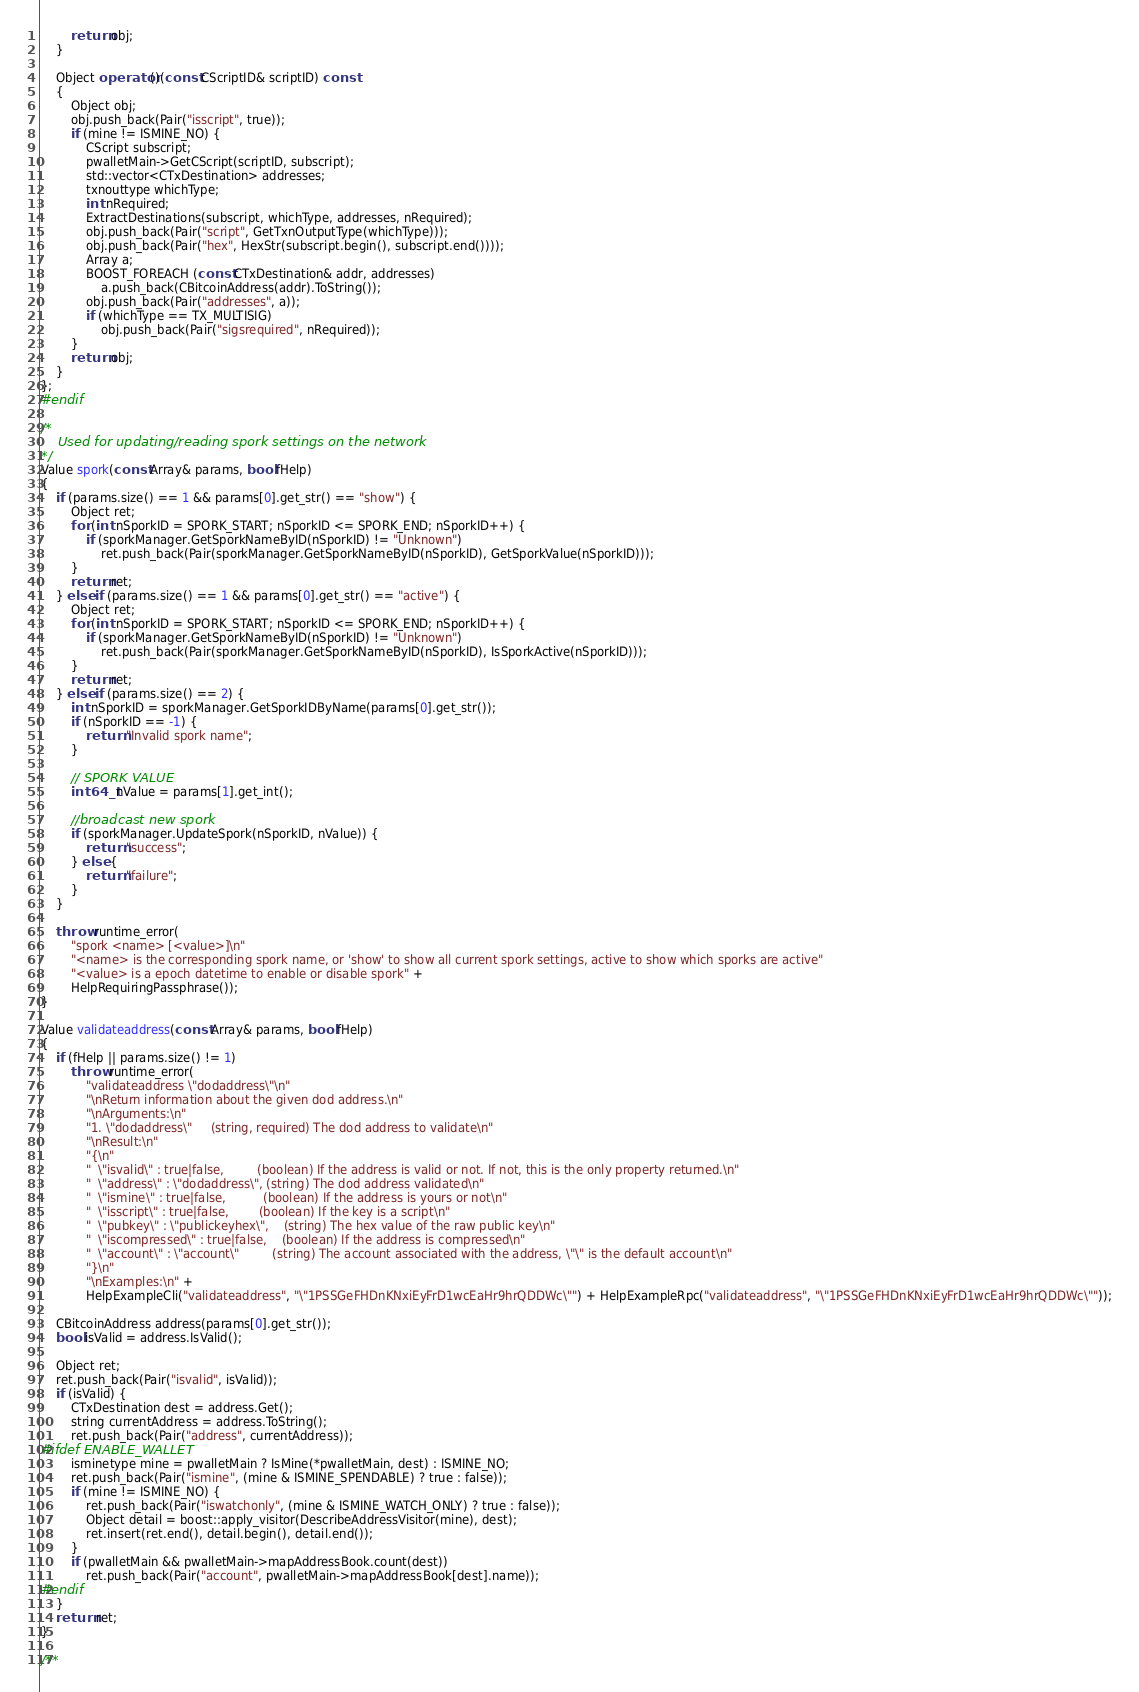<code> <loc_0><loc_0><loc_500><loc_500><_C++_>        return obj;
    }

    Object operator()(const CScriptID& scriptID) const
    {
        Object obj;
        obj.push_back(Pair("isscript", true));
        if (mine != ISMINE_NO) {
            CScript subscript;
            pwalletMain->GetCScript(scriptID, subscript);
            std::vector<CTxDestination> addresses;
            txnouttype whichType;
            int nRequired;
            ExtractDestinations(subscript, whichType, addresses, nRequired);
            obj.push_back(Pair("script", GetTxnOutputType(whichType)));
            obj.push_back(Pair("hex", HexStr(subscript.begin(), subscript.end())));
            Array a;
            BOOST_FOREACH (const CTxDestination& addr, addresses)
                a.push_back(CBitcoinAddress(addr).ToString());
            obj.push_back(Pair("addresses", a));
            if (whichType == TX_MULTISIG)
                obj.push_back(Pair("sigsrequired", nRequired));
        }
        return obj;
    }
};
#endif

/*
    Used for updating/reading spork settings on the network
*/
Value spork(const Array& params, bool fHelp)
{
    if (params.size() == 1 && params[0].get_str() == "show") {
        Object ret;
        for (int nSporkID = SPORK_START; nSporkID <= SPORK_END; nSporkID++) {
            if (sporkManager.GetSporkNameByID(nSporkID) != "Unknown")
                ret.push_back(Pair(sporkManager.GetSporkNameByID(nSporkID), GetSporkValue(nSporkID)));
        }
        return ret;
    } else if (params.size() == 1 && params[0].get_str() == "active") {
        Object ret;
        for (int nSporkID = SPORK_START; nSporkID <= SPORK_END; nSporkID++) {
            if (sporkManager.GetSporkNameByID(nSporkID) != "Unknown")
                ret.push_back(Pair(sporkManager.GetSporkNameByID(nSporkID), IsSporkActive(nSporkID)));
        }
        return ret;
    } else if (params.size() == 2) {
        int nSporkID = sporkManager.GetSporkIDByName(params[0].get_str());
        if (nSporkID == -1) {
            return "Invalid spork name";
        }

        // SPORK VALUE
        int64_t nValue = params[1].get_int();

        //broadcast new spork
        if (sporkManager.UpdateSpork(nSporkID, nValue)) {
            return "success";
        } else {
            return "failure";
        }
    }

    throw runtime_error(
        "spork <name> [<value>]\n"
        "<name> is the corresponding spork name, or 'show' to show all current spork settings, active to show which sporks are active"
        "<value> is a epoch datetime to enable or disable spork" +
        HelpRequiringPassphrase());
}

Value validateaddress(const Array& params, bool fHelp)
{
    if (fHelp || params.size() != 1)
        throw runtime_error(
            "validateaddress \"dodaddress\"\n"
            "\nReturn information about the given dod address.\n"
            "\nArguments:\n"
            "1. \"dodaddress\"     (string, required) The dod address to validate\n"
            "\nResult:\n"
            "{\n"
            "  \"isvalid\" : true|false,         (boolean) If the address is valid or not. If not, this is the only property returned.\n"
            "  \"address\" : \"dodaddress\", (string) The dod address validated\n"
            "  \"ismine\" : true|false,          (boolean) If the address is yours or not\n"
            "  \"isscript\" : true|false,        (boolean) If the key is a script\n"
            "  \"pubkey\" : \"publickeyhex\",    (string) The hex value of the raw public key\n"
            "  \"iscompressed\" : true|false,    (boolean) If the address is compressed\n"
            "  \"account\" : \"account\"         (string) The account associated with the address, \"\" is the default account\n"
            "}\n"
            "\nExamples:\n" +
            HelpExampleCli("validateaddress", "\"1PSSGeFHDnKNxiEyFrD1wcEaHr9hrQDDWc\"") + HelpExampleRpc("validateaddress", "\"1PSSGeFHDnKNxiEyFrD1wcEaHr9hrQDDWc\""));

    CBitcoinAddress address(params[0].get_str());
    bool isValid = address.IsValid();

    Object ret;
    ret.push_back(Pair("isvalid", isValid));
    if (isValid) {
        CTxDestination dest = address.Get();
        string currentAddress = address.ToString();
        ret.push_back(Pair("address", currentAddress));
#ifdef ENABLE_WALLET
        isminetype mine = pwalletMain ? IsMine(*pwalletMain, dest) : ISMINE_NO;
        ret.push_back(Pair("ismine", (mine & ISMINE_SPENDABLE) ? true : false));
        if (mine != ISMINE_NO) {
            ret.push_back(Pair("iswatchonly", (mine & ISMINE_WATCH_ONLY) ? true : false));
            Object detail = boost::apply_visitor(DescribeAddressVisitor(mine), dest);
            ret.insert(ret.end(), detail.begin(), detail.end());
        }
        if (pwalletMain && pwalletMain->mapAddressBook.count(dest))
            ret.push_back(Pair("account", pwalletMain->mapAddressBook[dest].name));
#endif
    }
    return ret;
}

/**</code> 